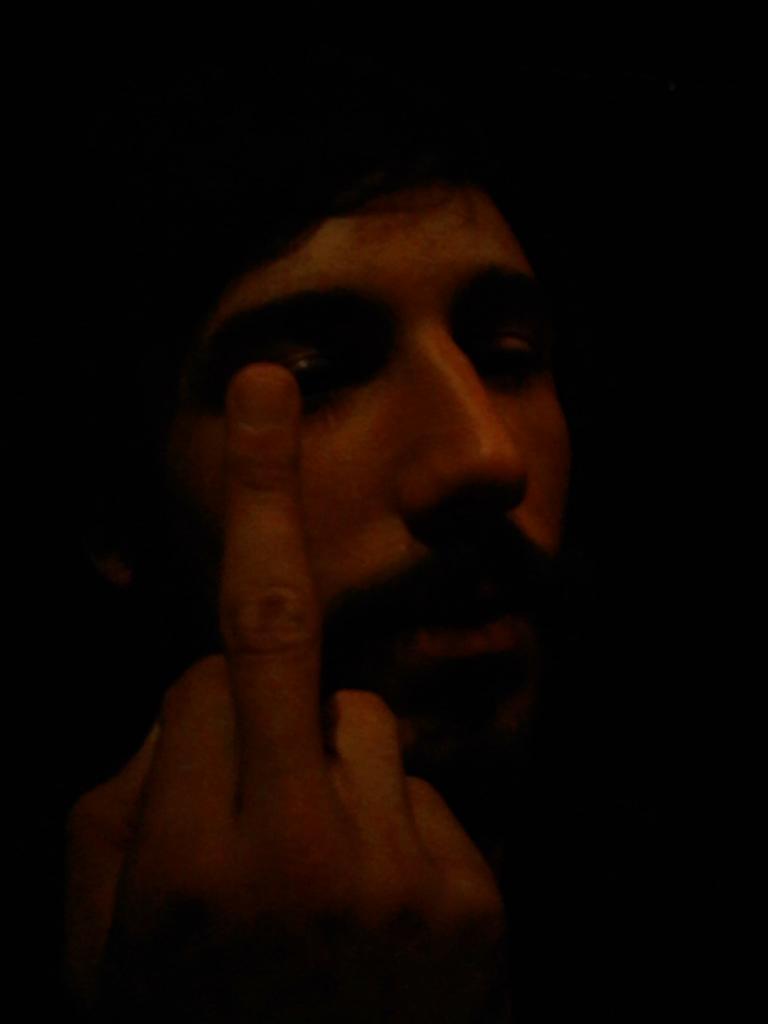Could you give a brief overview of what you see in this image? In this image, we can see a person showing his finger. Background there is a dark view. 